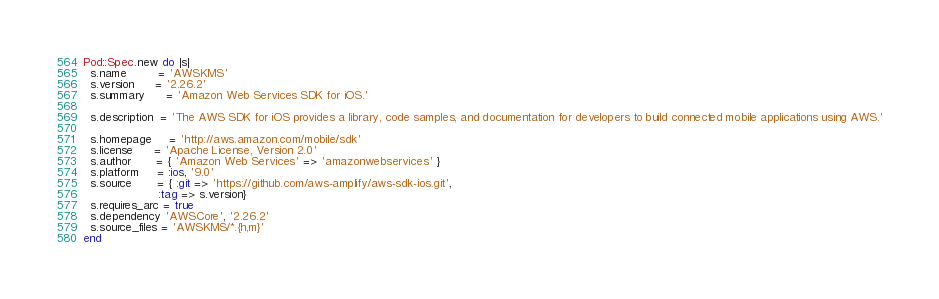Convert code to text. <code><loc_0><loc_0><loc_500><loc_500><_Ruby_>Pod::Spec.new do |s|
  s.name         = 'AWSKMS'
  s.version      = '2.26.2'
  s.summary      = 'Amazon Web Services SDK for iOS.'

  s.description  = 'The AWS SDK for iOS provides a library, code samples, and documentation for developers to build connected mobile applications using AWS.'

  s.homepage     = 'http://aws.amazon.com/mobile/sdk'
  s.license      = 'Apache License, Version 2.0'
  s.author       = { 'Amazon Web Services' => 'amazonwebservices' }
  s.platform     = :ios, '9.0'
  s.source       = { :git => 'https://github.com/aws-amplify/aws-sdk-ios.git',
                     :tag => s.version}
  s.requires_arc = true
  s.dependency 'AWSCore', '2.26.2'
  s.source_files = 'AWSKMS/*.{h,m}'
end
</code> 